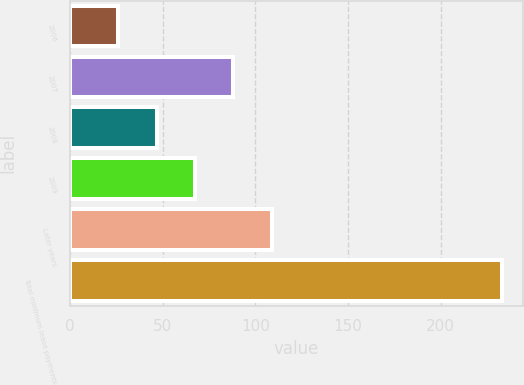<chart> <loc_0><loc_0><loc_500><loc_500><bar_chart><fcel>2006<fcel>2007<fcel>2008<fcel>2009<fcel>Later years<fcel>Total minimum lease payments<nl><fcel>26<fcel>88.1<fcel>46.7<fcel>67.4<fcel>108.8<fcel>233<nl></chart> 